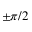Convert formula to latex. <formula><loc_0><loc_0><loc_500><loc_500>\pm \pi / 2</formula> 